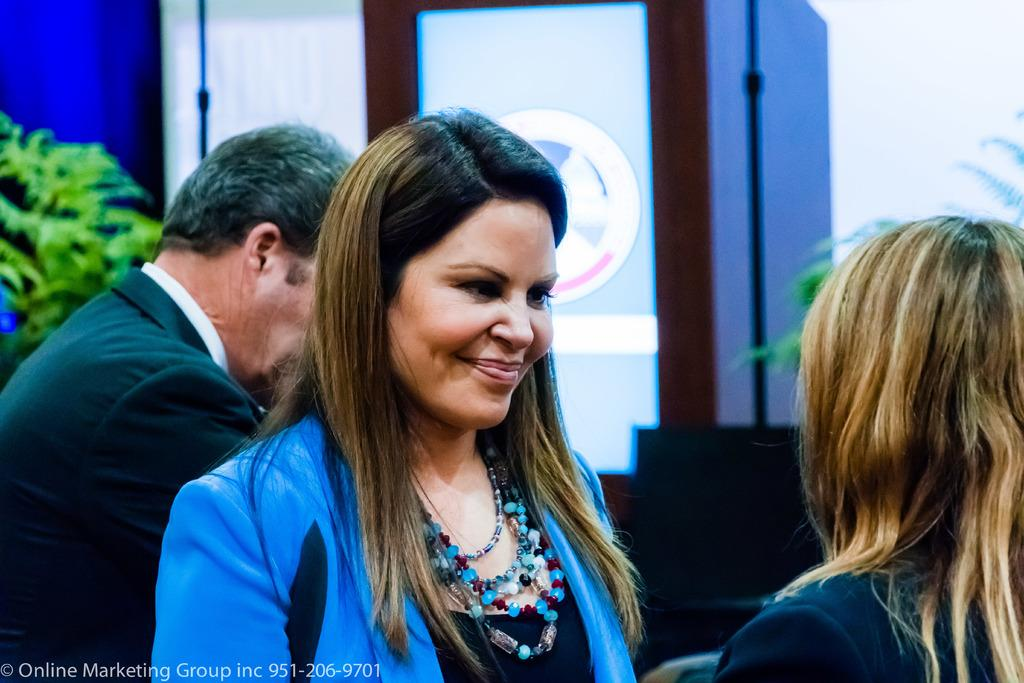Who or what is present in the image? There are people in the image. What can be seen in the background of the image? There is a wall and a door visible in the background. Are there any natural elements present in the image? Yes, there are plants in the image. What type of spoon can be seen in the image? There is no spoon present in the image. Is there a knife visible in the image? There is no knife present in the image. 